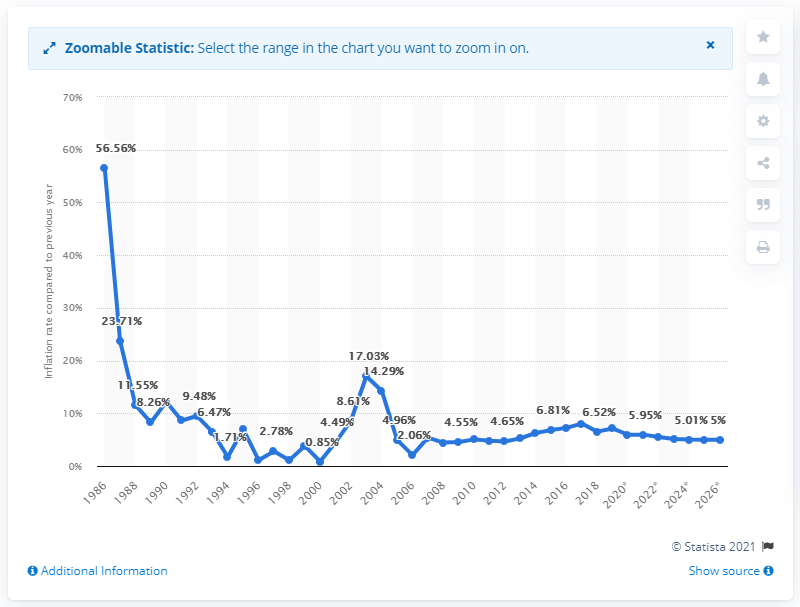List a handful of essential elements in this visual. In 1986, the average inflation rate in the Gambia was X. 